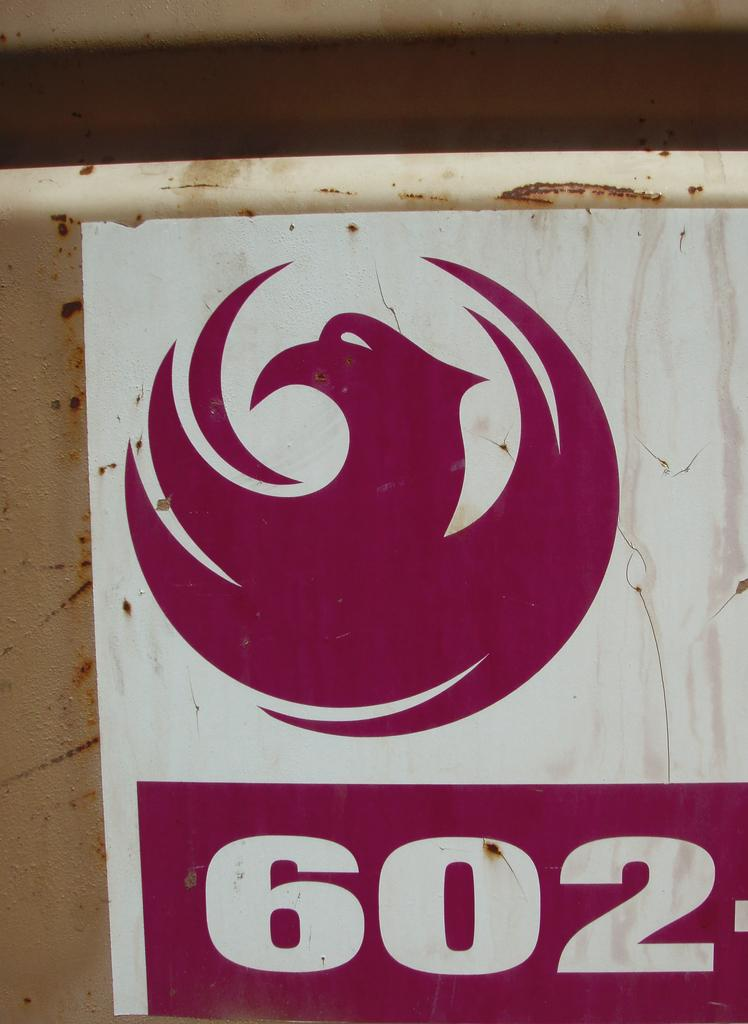<image>
Describe the image concisely. A sticker of a logo and the numeral "602". 